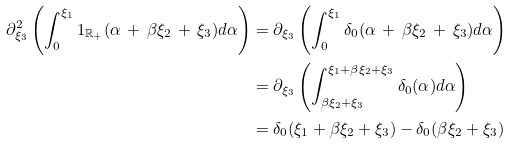<formula> <loc_0><loc_0><loc_500><loc_500>\partial _ { \xi _ { 3 } } ^ { 2 } \left ( \int _ { 0 } ^ { \xi _ { 1 } } 1 _ { \mathbb { R } _ { + } } ( \alpha \, + \, \beta \xi _ { 2 } \, + \, \xi _ { 3 } ) d \alpha \right ) & = \partial _ { \xi _ { 3 } } \left ( \int _ { 0 } ^ { \xi _ { 1 } } \delta _ { 0 } ( \alpha \, + \, \beta \xi _ { 2 } \, + \, \xi _ { 3 } ) d \alpha \right ) \\ & = \partial _ { \xi _ { 3 } } \left ( \int _ { \beta \xi _ { 2 } + \xi _ { 3 } } ^ { \xi _ { 1 } + \beta \xi _ { 2 } + \xi _ { 3 } } \delta _ { 0 } ( \alpha ) d \alpha \right ) \\ & = \delta _ { 0 } ( \xi _ { 1 } + \beta \xi _ { 2 } + \xi _ { 3 } ) - \delta _ { 0 } ( \beta \xi _ { 2 } + \xi _ { 3 } )</formula> 